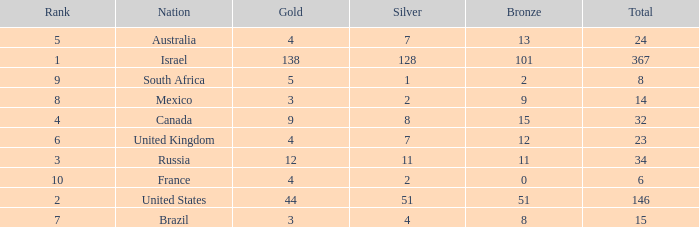What is the gold medal count for the country with a total greater than 32 and more than 128 silvers? None. 